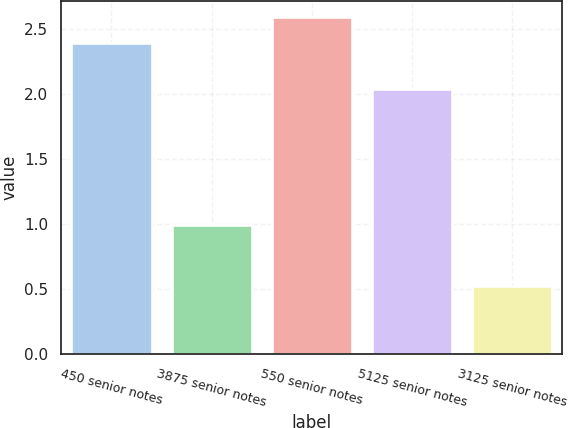<chart> <loc_0><loc_0><loc_500><loc_500><bar_chart><fcel>450 senior notes<fcel>3875 senior notes<fcel>550 senior notes<fcel>5125 senior notes<fcel>3125 senior notes<nl><fcel>2.39<fcel>0.99<fcel>2.59<fcel>2.04<fcel>0.52<nl></chart> 